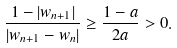Convert formula to latex. <formula><loc_0><loc_0><loc_500><loc_500>\frac { 1 - | w _ { n + 1 } | } { | w _ { n + 1 } - w _ { n } | } \geq \frac { 1 - a } { 2 a } > 0 .</formula> 